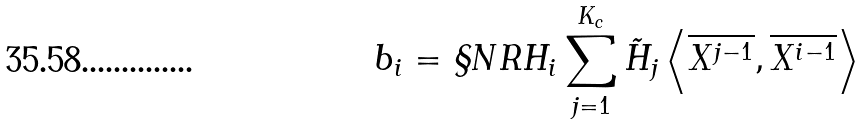Convert formula to latex. <formula><loc_0><loc_0><loc_500><loc_500>b _ { i } = \S N R H _ { i } \sum _ { j = 1 } ^ { K _ { c } } \tilde { H } _ { j } \left < \overline { X ^ { j - 1 } } , \overline { X ^ { i - 1 } } \right ></formula> 